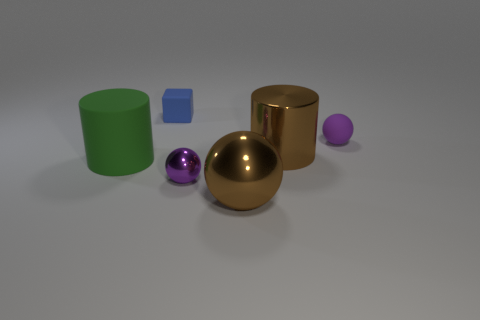Is the material of the large object that is to the left of the blue rubber block the same as the cube?
Offer a terse response. Yes. Are there any blue metallic objects that have the same shape as the green thing?
Provide a succinct answer. No. Are there an equal number of big shiny things behind the green matte cylinder and large brown cylinders?
Make the answer very short. Yes. There is a tiny object that is behind the tiny rubber thing that is on the right side of the big sphere; what is it made of?
Offer a very short reply. Rubber. What is the shape of the green rubber thing?
Make the answer very short. Cylinder. Is the number of green cylinders that are to the left of the large green object the same as the number of blue rubber things right of the purple metallic object?
Your answer should be compact. Yes. There is a matte object on the right side of the large sphere; is its color the same as the small sphere that is left of the purple matte sphere?
Offer a terse response. Yes. Are there more brown metal things in front of the big brown shiny cylinder than small red things?
Give a very brief answer. Yes. There is a tiny purple object that is the same material as the big green thing; what shape is it?
Ensure brevity in your answer.  Sphere. There is a ball that is in front of the purple metal thing; is its size the same as the purple matte sphere?
Offer a terse response. No. 